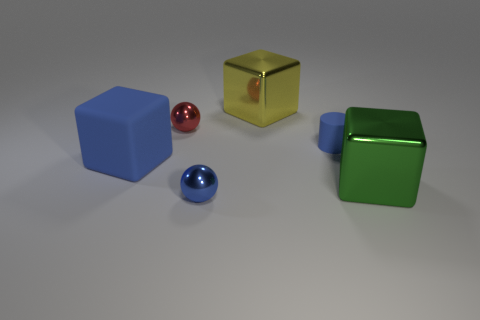Are there any tiny blue cylinders in front of the green thing?
Make the answer very short. No. How many small red objects are the same material as the big yellow object?
Provide a succinct answer. 1. What number of things are either small metal things or tiny gray shiny things?
Ensure brevity in your answer.  2. Are any large yellow metallic things visible?
Provide a succinct answer. Yes. The tiny sphere that is in front of the tiny metal ball that is behind the big rubber cube that is on the left side of the tiny blue metallic ball is made of what material?
Make the answer very short. Metal. Are there fewer yellow metal blocks right of the red shiny thing than tiny balls?
Ensure brevity in your answer.  Yes. There is a blue cube that is the same size as the green cube; what material is it?
Ensure brevity in your answer.  Rubber. There is a metallic object that is in front of the small blue rubber thing and left of the green object; what is its size?
Your answer should be compact. Small. There is another thing that is the same shape as the red thing; what size is it?
Keep it short and to the point. Small. What number of things are either tiny objects or objects that are on the left side of the large yellow metallic block?
Keep it short and to the point. 4. 